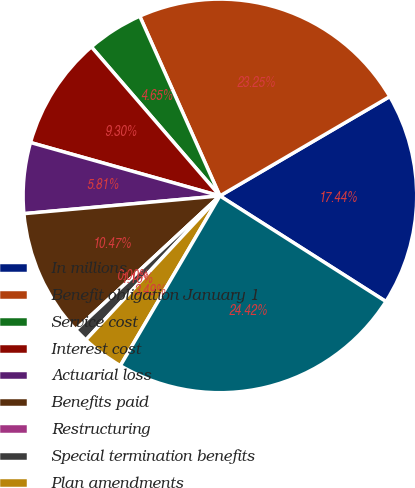<chart> <loc_0><loc_0><loc_500><loc_500><pie_chart><fcel>In millions<fcel>Benefit obligation January 1<fcel>Service cost<fcel>Interest cost<fcel>Actuarial loss<fcel>Benefits paid<fcel>Restructuring<fcel>Special termination benefits<fcel>Plan amendments<fcel>Benefit obligation December 31<nl><fcel>17.44%<fcel>23.25%<fcel>4.65%<fcel>9.3%<fcel>5.81%<fcel>10.47%<fcel>0.0%<fcel>1.16%<fcel>3.49%<fcel>24.42%<nl></chart> 